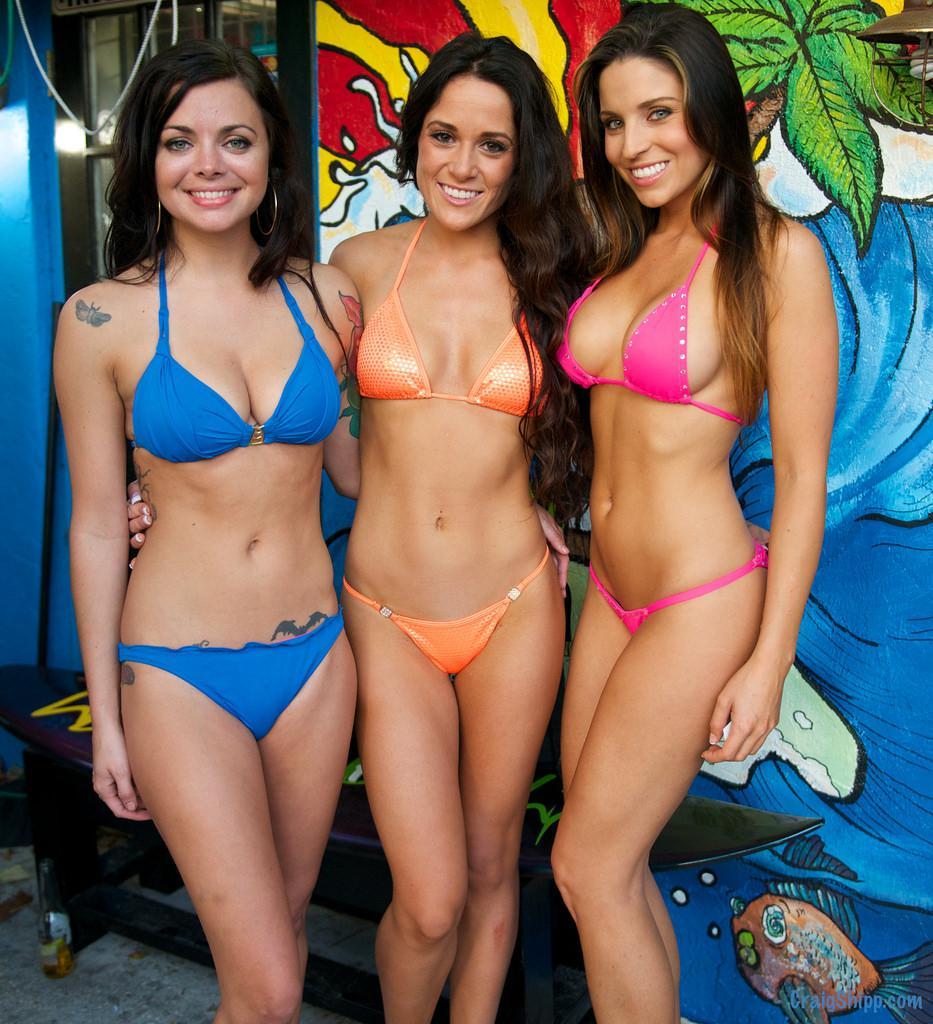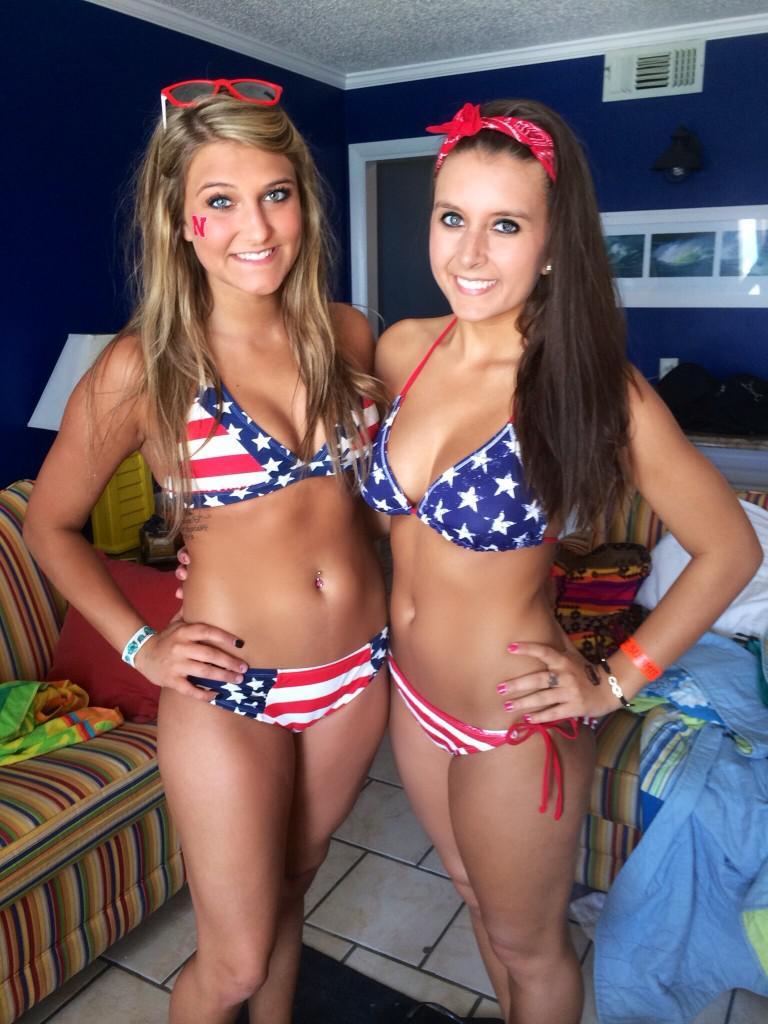The first image is the image on the left, the second image is the image on the right. Evaluate the accuracy of this statement regarding the images: "Two women are posing in bikinis in the image on the left.". Is it true? Answer yes or no. No. The first image is the image on the left, the second image is the image on the right. Analyze the images presented: Is the assertion "An image shows exactly three bikini models posed side-by-side, and at least one wears an orange bikini bottom." valid? Answer yes or no. Yes. 